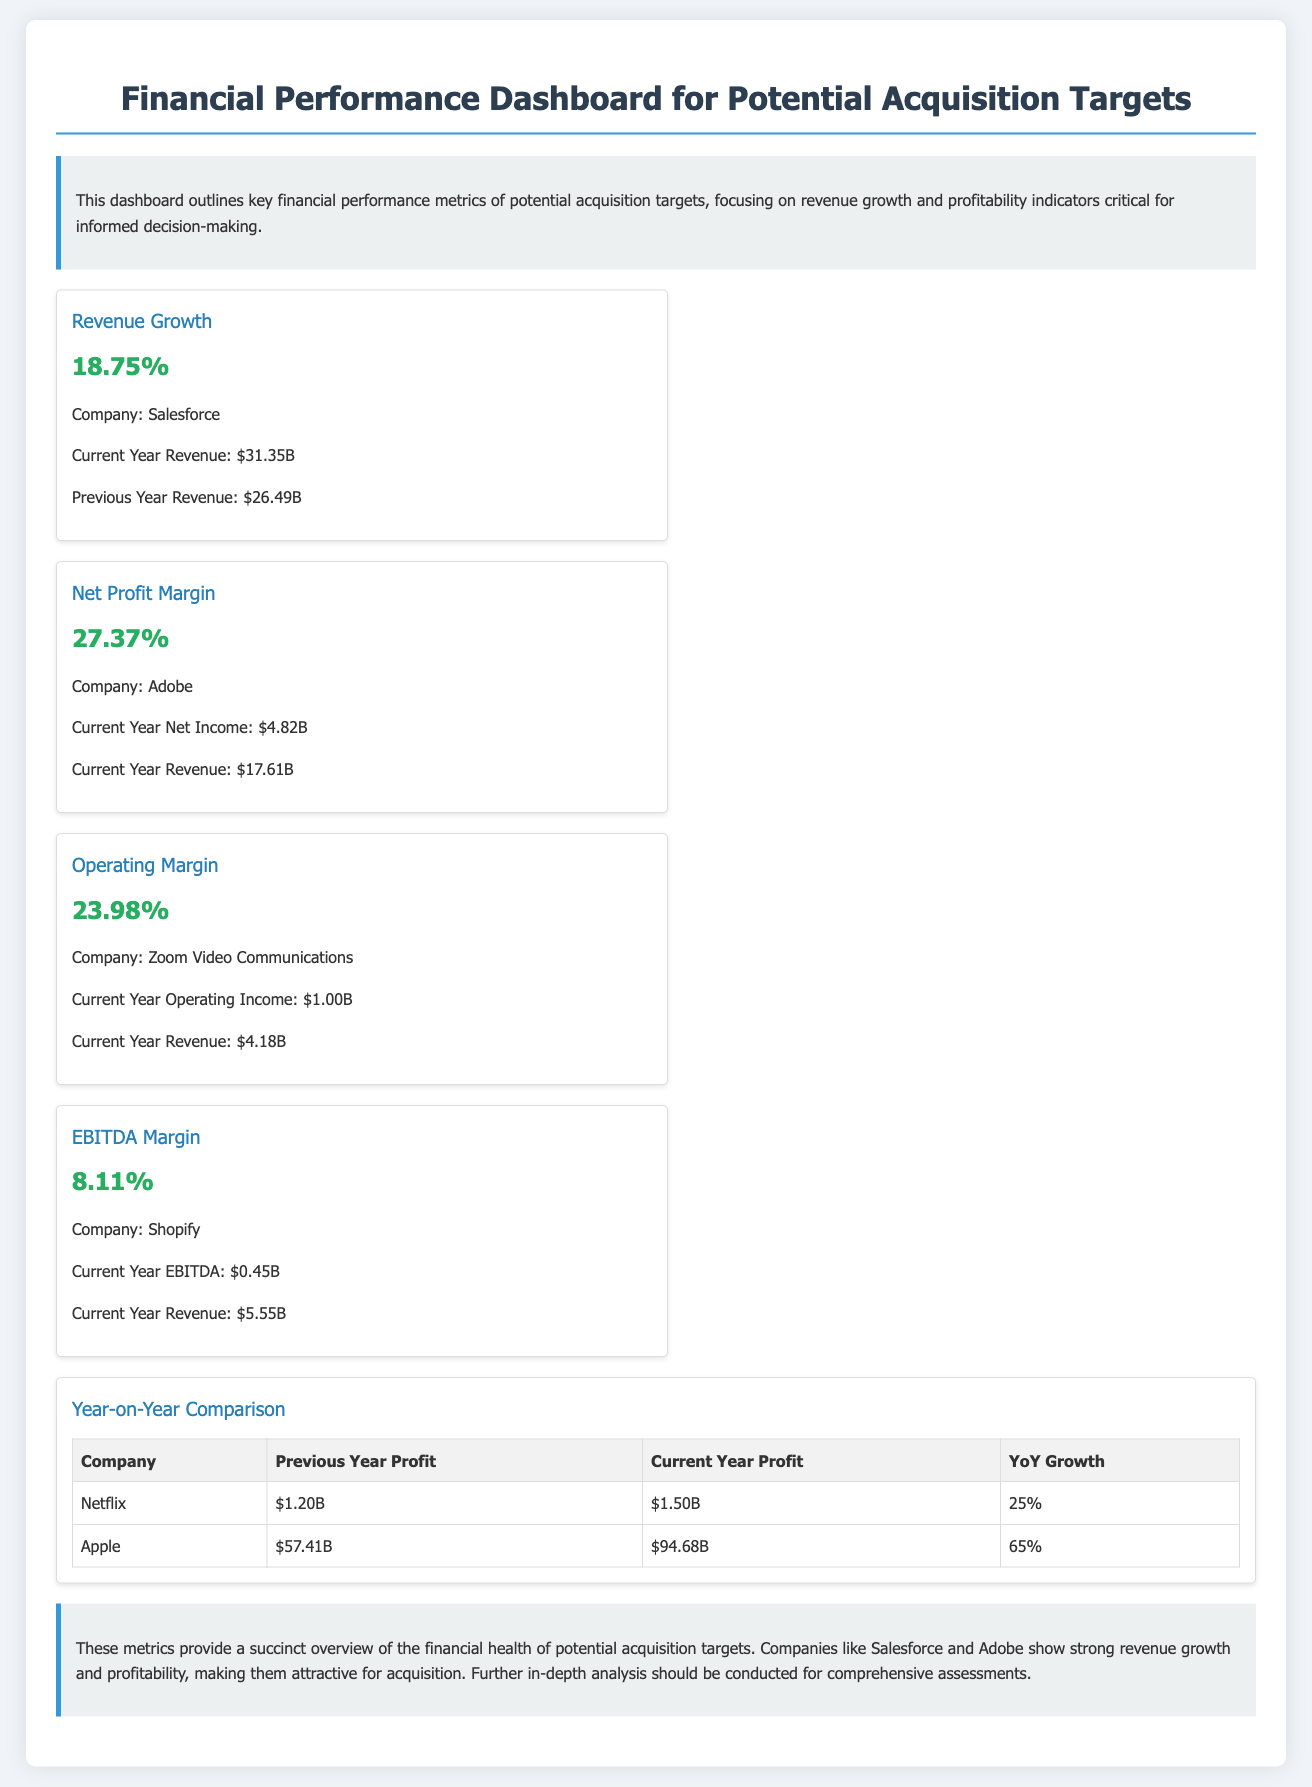What is the revenue growth of Salesforce? The revenue growth for Salesforce is specifically mentioned as 18.75%.
Answer: 18.75% What is the net profit margin for Adobe? The net profit margin for Adobe is stated as 27.37%.
Answer: 27.37% What is the current year revenue for Shopify? The current year revenue for Shopify is provided as $5.55B.
Answer: $5.55B Which company has the highest Year-on-Year profit growth? The table shows that Apple has the highest Year-on-Year profit growth at 65%.
Answer: Apple What does the EBITDA margin for Shopify indicate? The document specifies the EBITDA margin for Shopify as 8.11%.
Answer: 8.11% How much was Netflix’s profit in the previous year? According to the Year-on-Year comparison, Netflix's previous year profit was $1.20B.
Answer: $1.20B Which company reported an operating margin of 23.98%? The document attributes the operating margin of 23.98% to Zoom Video Communications.
Answer: Zoom Video Communications What is the current year net income for Adobe? The current year net income for Adobe is listed as $4.82B.
Answer: $4.82B What summary does the conclusion provide about acquisition targets? The conclusion emphasizes strong revenue growth and profitability for attractive acquisition targets.
Answer: Strong revenue growth and profitability 